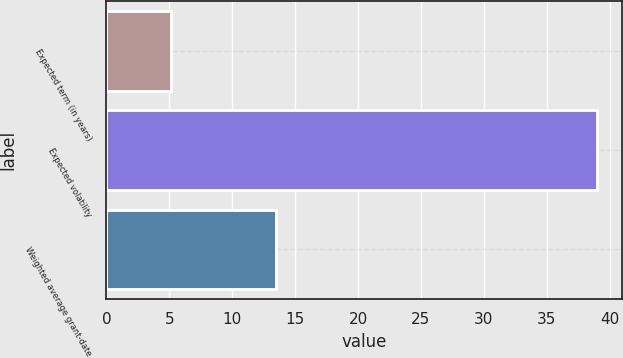Convert chart to OTSL. <chart><loc_0><loc_0><loc_500><loc_500><bar_chart><fcel>Expected term (in years)<fcel>Expected volatility<fcel>Weighted average grant-date<nl><fcel>5.16<fcel>39<fcel>13.47<nl></chart> 